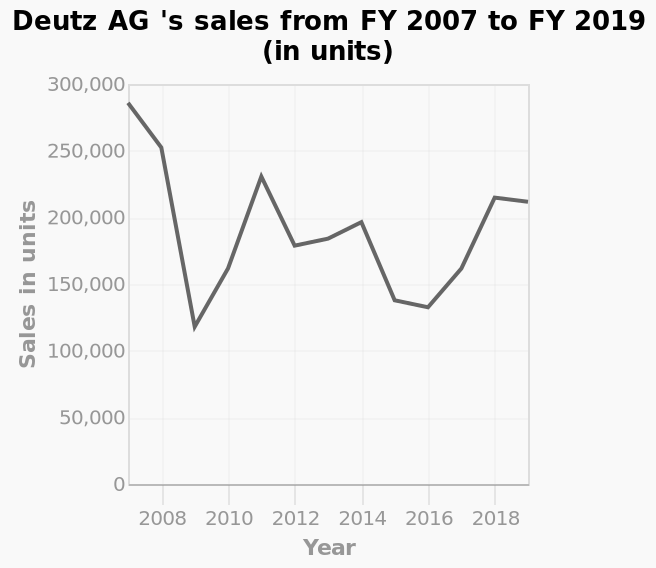<image>
please summary the statistics and relations of the chart Sales were at their highest in 2018 when this record began. However sales dropped to less than half within a year, then picked up but continued fluctuating until 2018. What is the title of the line chart?  The title of the line chart is "Deutz AG's sales from FY 2007 to FY 2019 (in units)." 